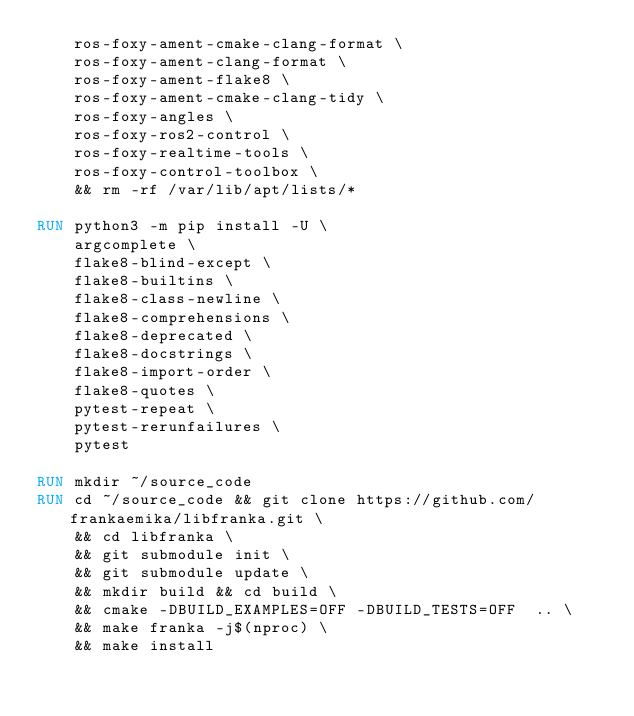<code> <loc_0><loc_0><loc_500><loc_500><_Dockerfile_>    ros-foxy-ament-cmake-clang-format \
    ros-foxy-ament-clang-format \
    ros-foxy-ament-flake8 \
    ros-foxy-ament-cmake-clang-tidy \
    ros-foxy-angles \
    ros-foxy-ros2-control \
    ros-foxy-realtime-tools \
    ros-foxy-control-toolbox \
    && rm -rf /var/lib/apt/lists/*

RUN python3 -m pip install -U \
    argcomplete \
    flake8-blind-except \
    flake8-builtins \
    flake8-class-newline \
    flake8-comprehensions \
    flake8-deprecated \
    flake8-docstrings \
    flake8-import-order \
    flake8-quotes \
    pytest-repeat \
    pytest-rerunfailures \
    pytest

RUN mkdir ~/source_code    
RUN cd ~/source_code && git clone https://github.com/frankaemika/libfranka.git \
    && cd libfranka \
    && git submodule init \
    && git submodule update \
    && mkdir build && cd build \
    && cmake -DBUILD_EXAMPLES=OFF -DBUILD_TESTS=OFF  .. \
    && make franka -j$(nproc) \
    && make install



</code> 